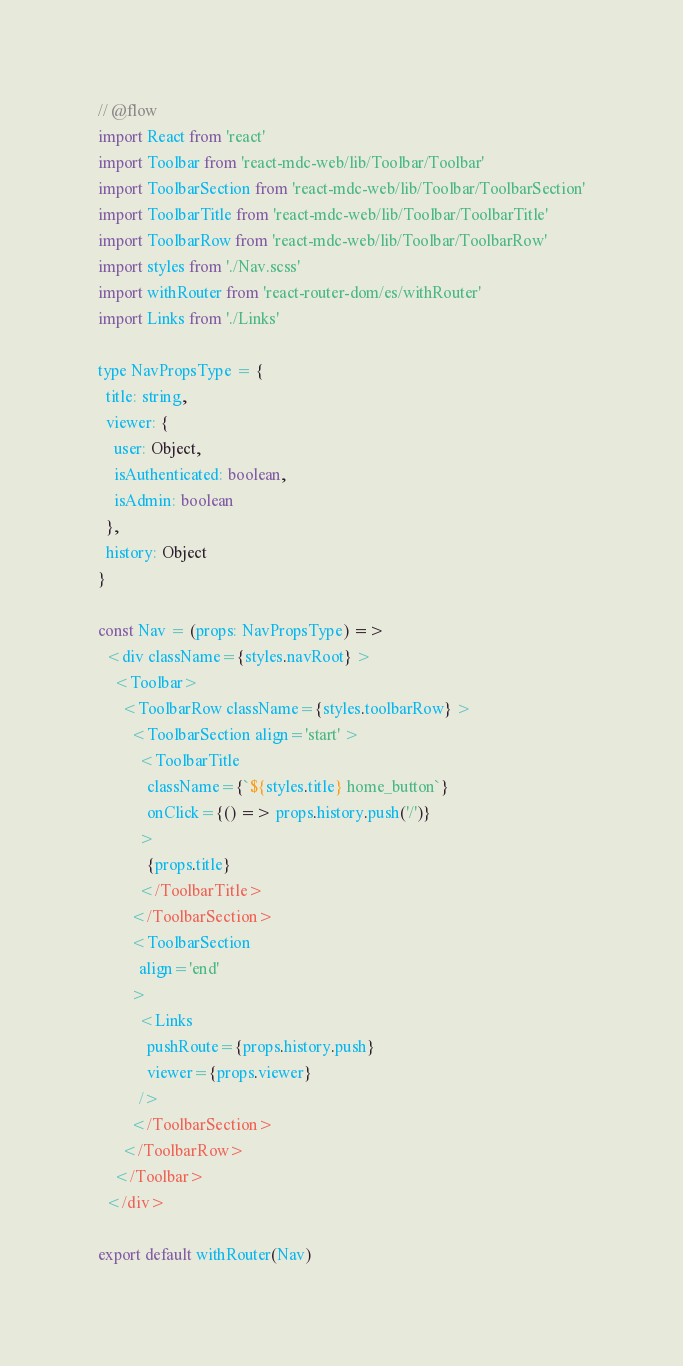Convert code to text. <code><loc_0><loc_0><loc_500><loc_500><_JavaScript_>// @flow
import React from 'react'
import Toolbar from 'react-mdc-web/lib/Toolbar/Toolbar'
import ToolbarSection from 'react-mdc-web/lib/Toolbar/ToolbarSection'
import ToolbarTitle from 'react-mdc-web/lib/Toolbar/ToolbarTitle'
import ToolbarRow from 'react-mdc-web/lib/Toolbar/ToolbarRow'
import styles from './Nav.scss'
import withRouter from 'react-router-dom/es/withRouter'
import Links from './Links'

type NavPropsType = {
  title: string,
  viewer: {
    user: Object,
    isAuthenticated: boolean,
    isAdmin: boolean
  },
  history: Object
}

const Nav = (props: NavPropsType) =>
  <div className={styles.navRoot} >
    <Toolbar>
      <ToolbarRow className={styles.toolbarRow} >
        <ToolbarSection align='start' >
          <ToolbarTitle
            className={`${styles.title} home_button`}
            onClick={() => props.history.push('/')}
          >
            {props.title}
          </ToolbarTitle>
        </ToolbarSection>
        <ToolbarSection
          align='end'
        >
          <Links
            pushRoute={props.history.push}
            viewer={props.viewer}
          />
        </ToolbarSection>
      </ToolbarRow>
    </Toolbar>
  </div>

export default withRouter(Nav)
</code> 